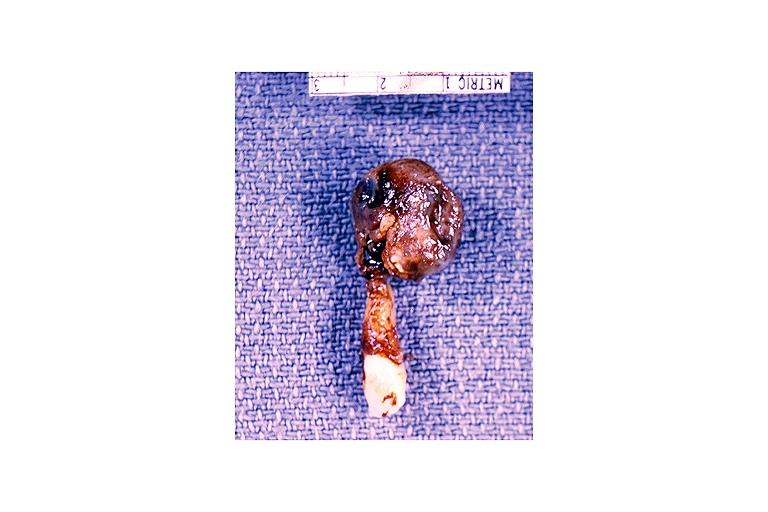s oral present?
Answer the question using a single word or phrase. Yes 